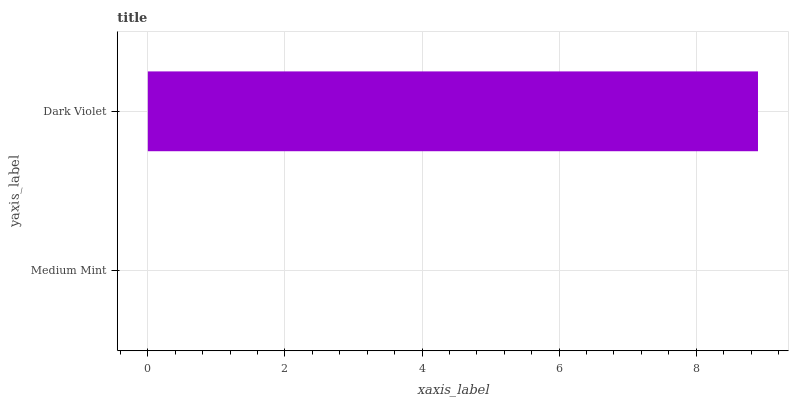Is Medium Mint the minimum?
Answer yes or no. Yes. Is Dark Violet the maximum?
Answer yes or no. Yes. Is Dark Violet the minimum?
Answer yes or no. No. Is Dark Violet greater than Medium Mint?
Answer yes or no. Yes. Is Medium Mint less than Dark Violet?
Answer yes or no. Yes. Is Medium Mint greater than Dark Violet?
Answer yes or no. No. Is Dark Violet less than Medium Mint?
Answer yes or no. No. Is Dark Violet the high median?
Answer yes or no. Yes. Is Medium Mint the low median?
Answer yes or no. Yes. Is Medium Mint the high median?
Answer yes or no. No. Is Dark Violet the low median?
Answer yes or no. No. 